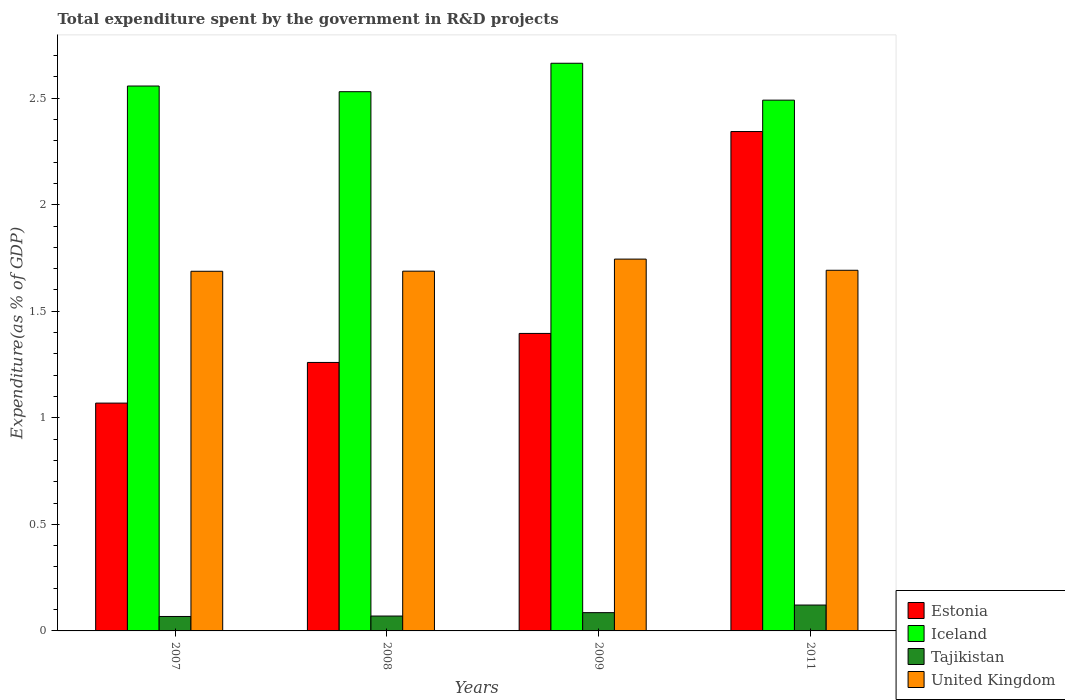How many different coloured bars are there?
Offer a terse response. 4. Are the number of bars on each tick of the X-axis equal?
Give a very brief answer. Yes. How many bars are there on the 4th tick from the left?
Give a very brief answer. 4. What is the label of the 1st group of bars from the left?
Your answer should be very brief. 2007. In how many cases, is the number of bars for a given year not equal to the number of legend labels?
Ensure brevity in your answer.  0. What is the total expenditure spent by the government in R&D projects in Estonia in 2008?
Provide a succinct answer. 1.26. Across all years, what is the maximum total expenditure spent by the government in R&D projects in United Kingdom?
Your response must be concise. 1.75. Across all years, what is the minimum total expenditure spent by the government in R&D projects in Iceland?
Your answer should be very brief. 2.49. What is the total total expenditure spent by the government in R&D projects in United Kingdom in the graph?
Your answer should be very brief. 6.81. What is the difference between the total expenditure spent by the government in R&D projects in Iceland in 2009 and that in 2011?
Give a very brief answer. 0.17. What is the difference between the total expenditure spent by the government in R&D projects in Tajikistan in 2007 and the total expenditure spent by the government in R&D projects in Iceland in 2008?
Ensure brevity in your answer.  -2.46. What is the average total expenditure spent by the government in R&D projects in Iceland per year?
Give a very brief answer. 2.56. In the year 2007, what is the difference between the total expenditure spent by the government in R&D projects in Estonia and total expenditure spent by the government in R&D projects in United Kingdom?
Ensure brevity in your answer.  -0.62. In how many years, is the total expenditure spent by the government in R&D projects in Iceland greater than 2.2 %?
Your answer should be compact. 4. What is the ratio of the total expenditure spent by the government in R&D projects in Estonia in 2009 to that in 2011?
Your answer should be compact. 0.6. Is the total expenditure spent by the government in R&D projects in Tajikistan in 2007 less than that in 2011?
Keep it short and to the point. Yes. Is the difference between the total expenditure spent by the government in R&D projects in Estonia in 2007 and 2011 greater than the difference between the total expenditure spent by the government in R&D projects in United Kingdom in 2007 and 2011?
Give a very brief answer. No. What is the difference between the highest and the second highest total expenditure spent by the government in R&D projects in United Kingdom?
Offer a terse response. 0.05. What is the difference between the highest and the lowest total expenditure spent by the government in R&D projects in Tajikistan?
Keep it short and to the point. 0.05. Is the sum of the total expenditure spent by the government in R&D projects in Iceland in 2009 and 2011 greater than the maximum total expenditure spent by the government in R&D projects in United Kingdom across all years?
Provide a succinct answer. Yes. What does the 1st bar from the left in 2007 represents?
Your response must be concise. Estonia. What does the 4th bar from the right in 2007 represents?
Give a very brief answer. Estonia. Does the graph contain any zero values?
Offer a very short reply. No. Does the graph contain grids?
Make the answer very short. No. Where does the legend appear in the graph?
Give a very brief answer. Bottom right. How many legend labels are there?
Provide a short and direct response. 4. How are the legend labels stacked?
Make the answer very short. Vertical. What is the title of the graph?
Offer a very short reply. Total expenditure spent by the government in R&D projects. Does "Sint Maarten (Dutch part)" appear as one of the legend labels in the graph?
Offer a very short reply. No. What is the label or title of the X-axis?
Offer a very short reply. Years. What is the label or title of the Y-axis?
Your answer should be compact. Expenditure(as % of GDP). What is the Expenditure(as % of GDP) of Estonia in 2007?
Ensure brevity in your answer.  1.07. What is the Expenditure(as % of GDP) in Iceland in 2007?
Keep it short and to the point. 2.56. What is the Expenditure(as % of GDP) of Tajikistan in 2007?
Keep it short and to the point. 0.07. What is the Expenditure(as % of GDP) of United Kingdom in 2007?
Keep it short and to the point. 1.69. What is the Expenditure(as % of GDP) in Estonia in 2008?
Your response must be concise. 1.26. What is the Expenditure(as % of GDP) in Iceland in 2008?
Provide a succinct answer. 2.53. What is the Expenditure(as % of GDP) in Tajikistan in 2008?
Make the answer very short. 0.07. What is the Expenditure(as % of GDP) in United Kingdom in 2008?
Make the answer very short. 1.69. What is the Expenditure(as % of GDP) in Estonia in 2009?
Offer a terse response. 1.4. What is the Expenditure(as % of GDP) of Iceland in 2009?
Offer a very short reply. 2.66. What is the Expenditure(as % of GDP) in Tajikistan in 2009?
Your answer should be very brief. 0.09. What is the Expenditure(as % of GDP) in United Kingdom in 2009?
Keep it short and to the point. 1.75. What is the Expenditure(as % of GDP) in Estonia in 2011?
Your answer should be compact. 2.34. What is the Expenditure(as % of GDP) in Iceland in 2011?
Your answer should be compact. 2.49. What is the Expenditure(as % of GDP) of Tajikistan in 2011?
Your answer should be very brief. 0.12. What is the Expenditure(as % of GDP) of United Kingdom in 2011?
Keep it short and to the point. 1.69. Across all years, what is the maximum Expenditure(as % of GDP) of Estonia?
Make the answer very short. 2.34. Across all years, what is the maximum Expenditure(as % of GDP) of Iceland?
Offer a terse response. 2.66. Across all years, what is the maximum Expenditure(as % of GDP) in Tajikistan?
Your response must be concise. 0.12. Across all years, what is the maximum Expenditure(as % of GDP) of United Kingdom?
Your response must be concise. 1.75. Across all years, what is the minimum Expenditure(as % of GDP) of Estonia?
Keep it short and to the point. 1.07. Across all years, what is the minimum Expenditure(as % of GDP) of Iceland?
Ensure brevity in your answer.  2.49. Across all years, what is the minimum Expenditure(as % of GDP) of Tajikistan?
Give a very brief answer. 0.07. Across all years, what is the minimum Expenditure(as % of GDP) in United Kingdom?
Offer a terse response. 1.69. What is the total Expenditure(as % of GDP) of Estonia in the graph?
Provide a succinct answer. 6.07. What is the total Expenditure(as % of GDP) of Iceland in the graph?
Make the answer very short. 10.24. What is the total Expenditure(as % of GDP) in Tajikistan in the graph?
Provide a short and direct response. 0.34. What is the total Expenditure(as % of GDP) of United Kingdom in the graph?
Offer a terse response. 6.81. What is the difference between the Expenditure(as % of GDP) in Estonia in 2007 and that in 2008?
Offer a very short reply. -0.19. What is the difference between the Expenditure(as % of GDP) in Iceland in 2007 and that in 2008?
Offer a very short reply. 0.03. What is the difference between the Expenditure(as % of GDP) of Tajikistan in 2007 and that in 2008?
Your response must be concise. -0. What is the difference between the Expenditure(as % of GDP) of United Kingdom in 2007 and that in 2008?
Ensure brevity in your answer.  -0. What is the difference between the Expenditure(as % of GDP) of Estonia in 2007 and that in 2009?
Provide a succinct answer. -0.33. What is the difference between the Expenditure(as % of GDP) in Iceland in 2007 and that in 2009?
Provide a short and direct response. -0.11. What is the difference between the Expenditure(as % of GDP) in Tajikistan in 2007 and that in 2009?
Your response must be concise. -0.02. What is the difference between the Expenditure(as % of GDP) in United Kingdom in 2007 and that in 2009?
Offer a very short reply. -0.06. What is the difference between the Expenditure(as % of GDP) in Estonia in 2007 and that in 2011?
Ensure brevity in your answer.  -1.27. What is the difference between the Expenditure(as % of GDP) of Iceland in 2007 and that in 2011?
Ensure brevity in your answer.  0.07. What is the difference between the Expenditure(as % of GDP) of Tajikistan in 2007 and that in 2011?
Offer a very short reply. -0.05. What is the difference between the Expenditure(as % of GDP) in United Kingdom in 2007 and that in 2011?
Ensure brevity in your answer.  -0. What is the difference between the Expenditure(as % of GDP) in Estonia in 2008 and that in 2009?
Provide a succinct answer. -0.14. What is the difference between the Expenditure(as % of GDP) of Iceland in 2008 and that in 2009?
Make the answer very short. -0.13. What is the difference between the Expenditure(as % of GDP) of Tajikistan in 2008 and that in 2009?
Keep it short and to the point. -0.02. What is the difference between the Expenditure(as % of GDP) of United Kingdom in 2008 and that in 2009?
Offer a very short reply. -0.06. What is the difference between the Expenditure(as % of GDP) in Estonia in 2008 and that in 2011?
Offer a terse response. -1.08. What is the difference between the Expenditure(as % of GDP) in Iceland in 2008 and that in 2011?
Ensure brevity in your answer.  0.04. What is the difference between the Expenditure(as % of GDP) of Tajikistan in 2008 and that in 2011?
Your answer should be compact. -0.05. What is the difference between the Expenditure(as % of GDP) in United Kingdom in 2008 and that in 2011?
Keep it short and to the point. -0. What is the difference between the Expenditure(as % of GDP) in Estonia in 2009 and that in 2011?
Ensure brevity in your answer.  -0.95. What is the difference between the Expenditure(as % of GDP) in Iceland in 2009 and that in 2011?
Your answer should be compact. 0.17. What is the difference between the Expenditure(as % of GDP) of Tajikistan in 2009 and that in 2011?
Your answer should be very brief. -0.04. What is the difference between the Expenditure(as % of GDP) in United Kingdom in 2009 and that in 2011?
Offer a terse response. 0.05. What is the difference between the Expenditure(as % of GDP) of Estonia in 2007 and the Expenditure(as % of GDP) of Iceland in 2008?
Offer a terse response. -1.46. What is the difference between the Expenditure(as % of GDP) in Estonia in 2007 and the Expenditure(as % of GDP) in Tajikistan in 2008?
Offer a very short reply. 1. What is the difference between the Expenditure(as % of GDP) of Estonia in 2007 and the Expenditure(as % of GDP) of United Kingdom in 2008?
Offer a terse response. -0.62. What is the difference between the Expenditure(as % of GDP) of Iceland in 2007 and the Expenditure(as % of GDP) of Tajikistan in 2008?
Provide a succinct answer. 2.49. What is the difference between the Expenditure(as % of GDP) in Iceland in 2007 and the Expenditure(as % of GDP) in United Kingdom in 2008?
Provide a short and direct response. 0.87. What is the difference between the Expenditure(as % of GDP) in Tajikistan in 2007 and the Expenditure(as % of GDP) in United Kingdom in 2008?
Provide a short and direct response. -1.62. What is the difference between the Expenditure(as % of GDP) in Estonia in 2007 and the Expenditure(as % of GDP) in Iceland in 2009?
Keep it short and to the point. -1.59. What is the difference between the Expenditure(as % of GDP) in Estonia in 2007 and the Expenditure(as % of GDP) in Tajikistan in 2009?
Your answer should be compact. 0.98. What is the difference between the Expenditure(as % of GDP) of Estonia in 2007 and the Expenditure(as % of GDP) of United Kingdom in 2009?
Your answer should be very brief. -0.68. What is the difference between the Expenditure(as % of GDP) in Iceland in 2007 and the Expenditure(as % of GDP) in Tajikistan in 2009?
Make the answer very short. 2.47. What is the difference between the Expenditure(as % of GDP) in Iceland in 2007 and the Expenditure(as % of GDP) in United Kingdom in 2009?
Keep it short and to the point. 0.81. What is the difference between the Expenditure(as % of GDP) in Tajikistan in 2007 and the Expenditure(as % of GDP) in United Kingdom in 2009?
Your response must be concise. -1.68. What is the difference between the Expenditure(as % of GDP) in Estonia in 2007 and the Expenditure(as % of GDP) in Iceland in 2011?
Offer a terse response. -1.42. What is the difference between the Expenditure(as % of GDP) in Estonia in 2007 and the Expenditure(as % of GDP) in Tajikistan in 2011?
Make the answer very short. 0.95. What is the difference between the Expenditure(as % of GDP) in Estonia in 2007 and the Expenditure(as % of GDP) in United Kingdom in 2011?
Make the answer very short. -0.62. What is the difference between the Expenditure(as % of GDP) in Iceland in 2007 and the Expenditure(as % of GDP) in Tajikistan in 2011?
Your answer should be very brief. 2.44. What is the difference between the Expenditure(as % of GDP) in Iceland in 2007 and the Expenditure(as % of GDP) in United Kingdom in 2011?
Offer a terse response. 0.86. What is the difference between the Expenditure(as % of GDP) of Tajikistan in 2007 and the Expenditure(as % of GDP) of United Kingdom in 2011?
Provide a succinct answer. -1.62. What is the difference between the Expenditure(as % of GDP) of Estonia in 2008 and the Expenditure(as % of GDP) of Iceland in 2009?
Ensure brevity in your answer.  -1.4. What is the difference between the Expenditure(as % of GDP) in Estonia in 2008 and the Expenditure(as % of GDP) in Tajikistan in 2009?
Your answer should be very brief. 1.17. What is the difference between the Expenditure(as % of GDP) in Estonia in 2008 and the Expenditure(as % of GDP) in United Kingdom in 2009?
Provide a short and direct response. -0.48. What is the difference between the Expenditure(as % of GDP) of Iceland in 2008 and the Expenditure(as % of GDP) of Tajikistan in 2009?
Your response must be concise. 2.44. What is the difference between the Expenditure(as % of GDP) of Iceland in 2008 and the Expenditure(as % of GDP) of United Kingdom in 2009?
Your response must be concise. 0.79. What is the difference between the Expenditure(as % of GDP) in Tajikistan in 2008 and the Expenditure(as % of GDP) in United Kingdom in 2009?
Ensure brevity in your answer.  -1.68. What is the difference between the Expenditure(as % of GDP) in Estonia in 2008 and the Expenditure(as % of GDP) in Iceland in 2011?
Give a very brief answer. -1.23. What is the difference between the Expenditure(as % of GDP) in Estonia in 2008 and the Expenditure(as % of GDP) in Tajikistan in 2011?
Your response must be concise. 1.14. What is the difference between the Expenditure(as % of GDP) of Estonia in 2008 and the Expenditure(as % of GDP) of United Kingdom in 2011?
Your answer should be compact. -0.43. What is the difference between the Expenditure(as % of GDP) in Iceland in 2008 and the Expenditure(as % of GDP) in Tajikistan in 2011?
Make the answer very short. 2.41. What is the difference between the Expenditure(as % of GDP) of Iceland in 2008 and the Expenditure(as % of GDP) of United Kingdom in 2011?
Provide a succinct answer. 0.84. What is the difference between the Expenditure(as % of GDP) of Tajikistan in 2008 and the Expenditure(as % of GDP) of United Kingdom in 2011?
Keep it short and to the point. -1.62. What is the difference between the Expenditure(as % of GDP) of Estonia in 2009 and the Expenditure(as % of GDP) of Iceland in 2011?
Provide a succinct answer. -1.09. What is the difference between the Expenditure(as % of GDP) in Estonia in 2009 and the Expenditure(as % of GDP) in Tajikistan in 2011?
Your answer should be compact. 1.27. What is the difference between the Expenditure(as % of GDP) of Estonia in 2009 and the Expenditure(as % of GDP) of United Kingdom in 2011?
Offer a very short reply. -0.3. What is the difference between the Expenditure(as % of GDP) in Iceland in 2009 and the Expenditure(as % of GDP) in Tajikistan in 2011?
Keep it short and to the point. 2.54. What is the difference between the Expenditure(as % of GDP) of Iceland in 2009 and the Expenditure(as % of GDP) of United Kingdom in 2011?
Make the answer very short. 0.97. What is the difference between the Expenditure(as % of GDP) in Tajikistan in 2009 and the Expenditure(as % of GDP) in United Kingdom in 2011?
Your response must be concise. -1.61. What is the average Expenditure(as % of GDP) in Estonia per year?
Your response must be concise. 1.52. What is the average Expenditure(as % of GDP) of Iceland per year?
Give a very brief answer. 2.56. What is the average Expenditure(as % of GDP) in Tajikistan per year?
Your answer should be compact. 0.09. What is the average Expenditure(as % of GDP) of United Kingdom per year?
Your answer should be very brief. 1.7. In the year 2007, what is the difference between the Expenditure(as % of GDP) in Estonia and Expenditure(as % of GDP) in Iceland?
Your answer should be very brief. -1.49. In the year 2007, what is the difference between the Expenditure(as % of GDP) of Estonia and Expenditure(as % of GDP) of United Kingdom?
Provide a short and direct response. -0.62. In the year 2007, what is the difference between the Expenditure(as % of GDP) in Iceland and Expenditure(as % of GDP) in Tajikistan?
Provide a succinct answer. 2.49. In the year 2007, what is the difference between the Expenditure(as % of GDP) of Iceland and Expenditure(as % of GDP) of United Kingdom?
Keep it short and to the point. 0.87. In the year 2007, what is the difference between the Expenditure(as % of GDP) of Tajikistan and Expenditure(as % of GDP) of United Kingdom?
Keep it short and to the point. -1.62. In the year 2008, what is the difference between the Expenditure(as % of GDP) of Estonia and Expenditure(as % of GDP) of Iceland?
Ensure brevity in your answer.  -1.27. In the year 2008, what is the difference between the Expenditure(as % of GDP) in Estonia and Expenditure(as % of GDP) in Tajikistan?
Offer a very short reply. 1.19. In the year 2008, what is the difference between the Expenditure(as % of GDP) of Estonia and Expenditure(as % of GDP) of United Kingdom?
Your answer should be very brief. -0.43. In the year 2008, what is the difference between the Expenditure(as % of GDP) in Iceland and Expenditure(as % of GDP) in Tajikistan?
Give a very brief answer. 2.46. In the year 2008, what is the difference between the Expenditure(as % of GDP) of Iceland and Expenditure(as % of GDP) of United Kingdom?
Make the answer very short. 0.84. In the year 2008, what is the difference between the Expenditure(as % of GDP) in Tajikistan and Expenditure(as % of GDP) in United Kingdom?
Make the answer very short. -1.62. In the year 2009, what is the difference between the Expenditure(as % of GDP) of Estonia and Expenditure(as % of GDP) of Iceland?
Ensure brevity in your answer.  -1.27. In the year 2009, what is the difference between the Expenditure(as % of GDP) of Estonia and Expenditure(as % of GDP) of Tajikistan?
Provide a short and direct response. 1.31. In the year 2009, what is the difference between the Expenditure(as % of GDP) in Estonia and Expenditure(as % of GDP) in United Kingdom?
Provide a succinct answer. -0.35. In the year 2009, what is the difference between the Expenditure(as % of GDP) in Iceland and Expenditure(as % of GDP) in Tajikistan?
Give a very brief answer. 2.58. In the year 2009, what is the difference between the Expenditure(as % of GDP) of Iceland and Expenditure(as % of GDP) of United Kingdom?
Your answer should be very brief. 0.92. In the year 2009, what is the difference between the Expenditure(as % of GDP) of Tajikistan and Expenditure(as % of GDP) of United Kingdom?
Make the answer very short. -1.66. In the year 2011, what is the difference between the Expenditure(as % of GDP) in Estonia and Expenditure(as % of GDP) in Iceland?
Your answer should be very brief. -0.15. In the year 2011, what is the difference between the Expenditure(as % of GDP) in Estonia and Expenditure(as % of GDP) in Tajikistan?
Keep it short and to the point. 2.22. In the year 2011, what is the difference between the Expenditure(as % of GDP) of Estonia and Expenditure(as % of GDP) of United Kingdom?
Provide a short and direct response. 0.65. In the year 2011, what is the difference between the Expenditure(as % of GDP) of Iceland and Expenditure(as % of GDP) of Tajikistan?
Your answer should be compact. 2.37. In the year 2011, what is the difference between the Expenditure(as % of GDP) in Iceland and Expenditure(as % of GDP) in United Kingdom?
Ensure brevity in your answer.  0.8. In the year 2011, what is the difference between the Expenditure(as % of GDP) in Tajikistan and Expenditure(as % of GDP) in United Kingdom?
Make the answer very short. -1.57. What is the ratio of the Expenditure(as % of GDP) of Estonia in 2007 to that in 2008?
Give a very brief answer. 0.85. What is the ratio of the Expenditure(as % of GDP) of Iceland in 2007 to that in 2008?
Your answer should be compact. 1.01. What is the ratio of the Expenditure(as % of GDP) in Tajikistan in 2007 to that in 2008?
Offer a terse response. 0.97. What is the ratio of the Expenditure(as % of GDP) of United Kingdom in 2007 to that in 2008?
Your answer should be very brief. 1. What is the ratio of the Expenditure(as % of GDP) in Estonia in 2007 to that in 2009?
Provide a short and direct response. 0.77. What is the ratio of the Expenditure(as % of GDP) in Iceland in 2007 to that in 2009?
Ensure brevity in your answer.  0.96. What is the ratio of the Expenditure(as % of GDP) in Tajikistan in 2007 to that in 2009?
Keep it short and to the point. 0.79. What is the ratio of the Expenditure(as % of GDP) of United Kingdom in 2007 to that in 2009?
Your answer should be compact. 0.97. What is the ratio of the Expenditure(as % of GDP) of Estonia in 2007 to that in 2011?
Provide a succinct answer. 0.46. What is the ratio of the Expenditure(as % of GDP) of Iceland in 2007 to that in 2011?
Offer a terse response. 1.03. What is the ratio of the Expenditure(as % of GDP) of Tajikistan in 2007 to that in 2011?
Offer a terse response. 0.56. What is the ratio of the Expenditure(as % of GDP) of United Kingdom in 2007 to that in 2011?
Provide a short and direct response. 1. What is the ratio of the Expenditure(as % of GDP) in Estonia in 2008 to that in 2009?
Ensure brevity in your answer.  0.9. What is the ratio of the Expenditure(as % of GDP) of Iceland in 2008 to that in 2009?
Offer a very short reply. 0.95. What is the ratio of the Expenditure(as % of GDP) in Tajikistan in 2008 to that in 2009?
Make the answer very short. 0.81. What is the ratio of the Expenditure(as % of GDP) in United Kingdom in 2008 to that in 2009?
Your response must be concise. 0.97. What is the ratio of the Expenditure(as % of GDP) in Estonia in 2008 to that in 2011?
Make the answer very short. 0.54. What is the ratio of the Expenditure(as % of GDP) of Iceland in 2008 to that in 2011?
Offer a terse response. 1.02. What is the ratio of the Expenditure(as % of GDP) of Tajikistan in 2008 to that in 2011?
Your answer should be compact. 0.57. What is the ratio of the Expenditure(as % of GDP) in Estonia in 2009 to that in 2011?
Your answer should be compact. 0.6. What is the ratio of the Expenditure(as % of GDP) of Iceland in 2009 to that in 2011?
Make the answer very short. 1.07. What is the ratio of the Expenditure(as % of GDP) of Tajikistan in 2009 to that in 2011?
Ensure brevity in your answer.  0.71. What is the ratio of the Expenditure(as % of GDP) in United Kingdom in 2009 to that in 2011?
Your answer should be compact. 1.03. What is the difference between the highest and the second highest Expenditure(as % of GDP) of Estonia?
Your response must be concise. 0.95. What is the difference between the highest and the second highest Expenditure(as % of GDP) in Iceland?
Provide a succinct answer. 0.11. What is the difference between the highest and the second highest Expenditure(as % of GDP) of Tajikistan?
Offer a terse response. 0.04. What is the difference between the highest and the second highest Expenditure(as % of GDP) in United Kingdom?
Provide a short and direct response. 0.05. What is the difference between the highest and the lowest Expenditure(as % of GDP) of Estonia?
Provide a succinct answer. 1.27. What is the difference between the highest and the lowest Expenditure(as % of GDP) of Iceland?
Offer a terse response. 0.17. What is the difference between the highest and the lowest Expenditure(as % of GDP) of Tajikistan?
Keep it short and to the point. 0.05. What is the difference between the highest and the lowest Expenditure(as % of GDP) of United Kingdom?
Offer a terse response. 0.06. 